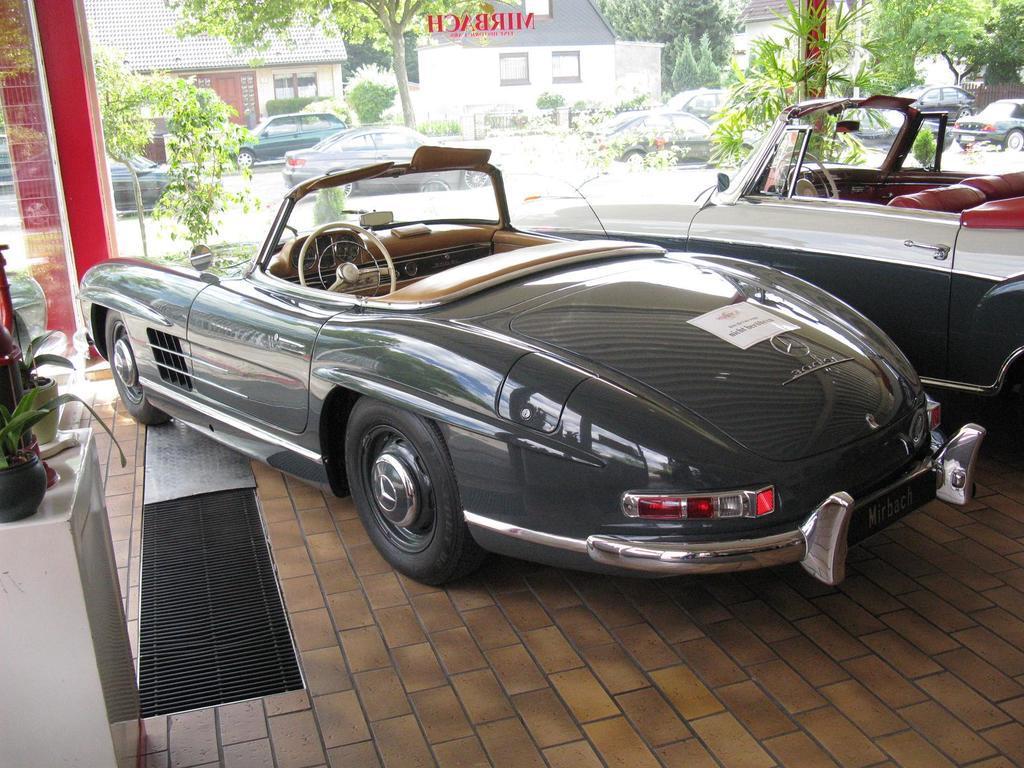Could you give a brief overview of what you see in this image? In this image I can see the vehicles. To the left I can see the flower pots. Through the glass I can see many trees, few vehicles on the road and the houses. 